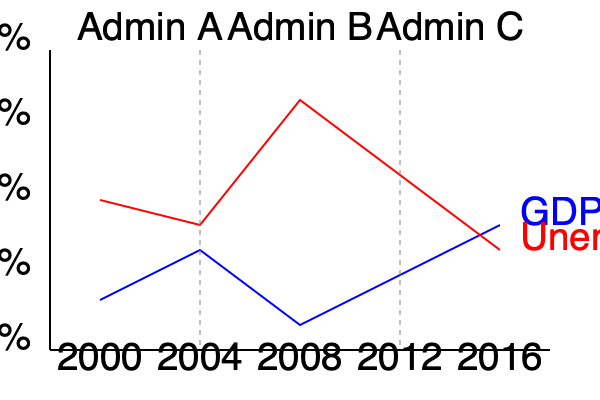Based on the economic indicators shown in the graph, which administration experienced the most significant economic challenge, and what policy approach might they have implemented to address it? To answer this question, we need to analyze the graph and interpret the economic indicators for each administration:

1. Administration A (2000-2004):
   - GDP growth: Moderate decline
   - Unemployment: Slight increase

2. Administration B (2004-2012):
   - GDP growth: Sharp decline followed by recovery
   - Unemployment: Sharp increase followed by gradual decrease

3. Administration C (2012-2016):
   - GDP growth: Steady increase
   - Unemployment: Continued decrease

Step 1: Identify the most significant economic challenge
Administration B faced the most significant economic challenge, as evidenced by:
- The sharpest decline in GDP growth
- The highest peak in unemployment rate

Step 2: Consider potential policy approaches
Given the severe economic downturn, Administration B likely implemented a combination of:
a) Fiscal stimulus: Increased government spending and tax cuts to boost economic activity
b) Monetary policy: Lowering interest rates to encourage borrowing and investment
c) Financial sector reforms: Addressing issues in the banking and finance industry
d) Job creation programs: Initiatives to reduce unemployment

Step 3: Evaluate the outcome
The graph shows that after the initial economic shock:
- GDP growth began to recover
- Unemployment started to decrease, though more gradually

This suggests that the policy approach was effective in stabilizing the economy and initiating a recovery, albeit with a slower impact on unemployment.
Answer: Administration B faced the most significant challenge; likely implemented fiscal stimulus, monetary easing, financial reforms, and job creation programs. 